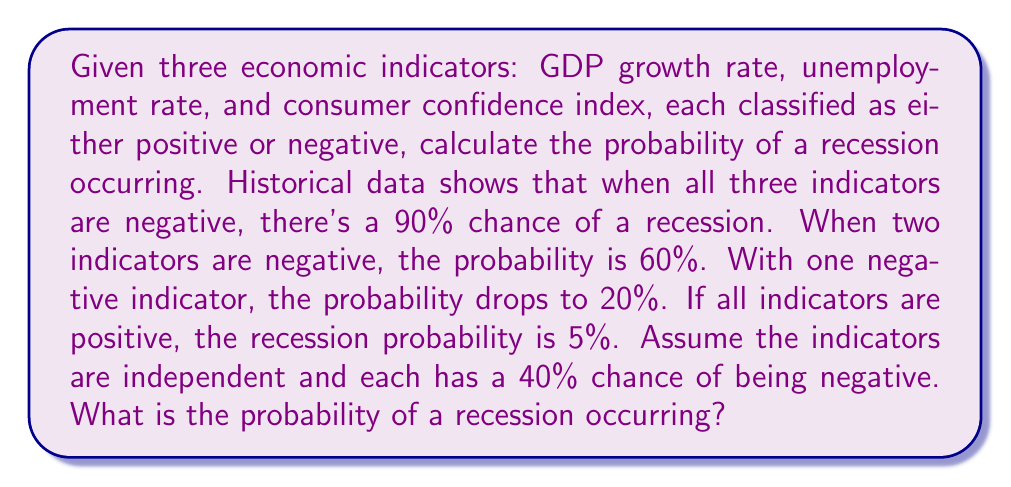Can you answer this question? Let's approach this step-by-step:

1) First, we need to calculate the probability of each possible combination of indicators:

   P(All negative) = $0.4 * 0.4 * 0.4 = 0.064$
   P(Two negative, one positive) = $3 * (0.4 * 0.4 * 0.6) = 0.288$
   P(One negative, two positive) = $3 * (0.4 * 0.6 * 0.6) = 0.432$
   P(All positive) = $0.6 * 0.6 * 0.6 = 0.216$

2) Now, we use the law of total probability. Let R be the event of a recession occurring:

   $$P(R) = P(R|A)P(A) + P(R|B)P(B) + P(R|C)P(C) + P(R|D)P(D)$$

   Where:
   A: All indicators negative
   B: Two indicators negative
   C: One indicator negative
   D: All indicators positive

3) Substituting the given probabilities:

   $$P(R) = 0.90 * 0.064 + 0.60 * 0.288 + 0.20 * 0.432 + 0.05 * 0.216$$

4) Calculate:

   $$P(R) = 0.0576 + 0.1728 + 0.0864 + 0.0108 = 0.3276$$

Therefore, the probability of a recession occurring is approximately 0.3276 or 32.76%.
Answer: 0.3276 